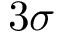Convert formula to latex. <formula><loc_0><loc_0><loc_500><loc_500>3 \sigma</formula> 